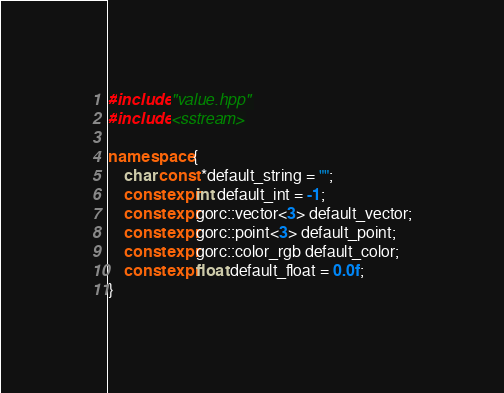<code> <loc_0><loc_0><loc_500><loc_500><_C++_>#include "value.hpp"
#include <sstream>

namespace {
    char const *default_string = "";
    constexpr int default_int = -1;
    constexpr gorc::vector<3> default_vector;
    constexpr gorc::point<3> default_point;
    constexpr gorc::color_rgb default_color;
    constexpr float default_float = 0.0f;
}
</code> 